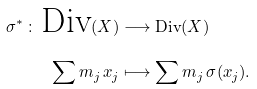Convert formula to latex. <formula><loc_0><loc_0><loc_500><loc_500>\sigma ^ { * } \, \colon \, \text {Div} ( X ) & \longrightarrow \text {Div} ( X ) \\ \sum m _ { j } \, x _ { j } & \longmapsto \sum m _ { j } \, \sigma ( x _ { j } ) .</formula> 